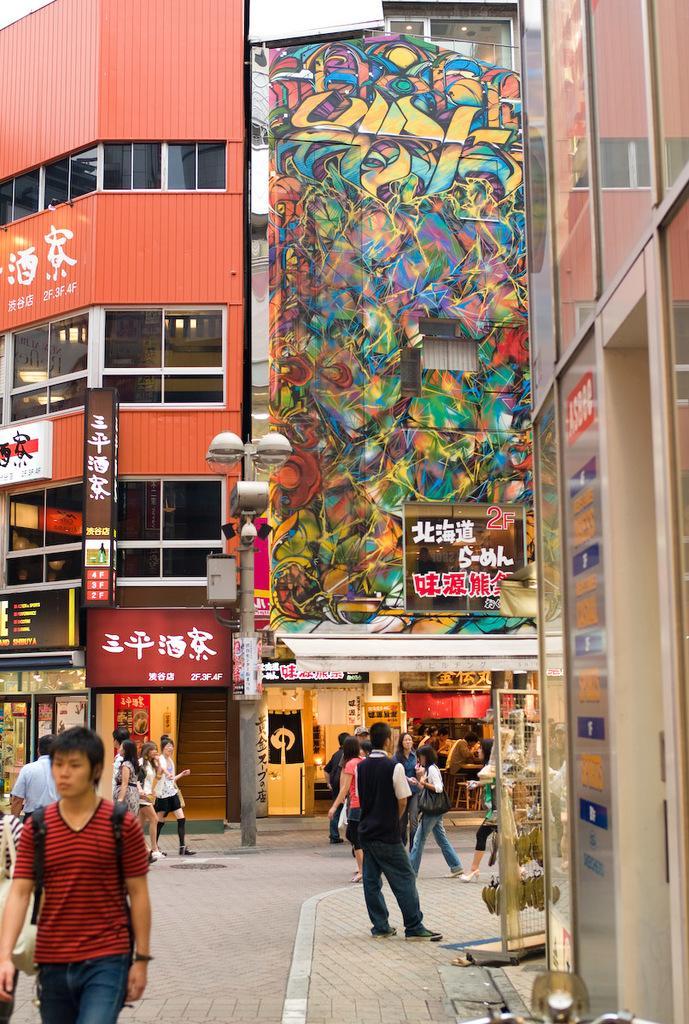Could you give a brief overview of what you see in this image? In this image we can see a road. There are many people. Also there is a sidewalk. Some are wearing bags. And there are buildings with name boards. Also there is a wall with graffiti. And there are windows for the building. 